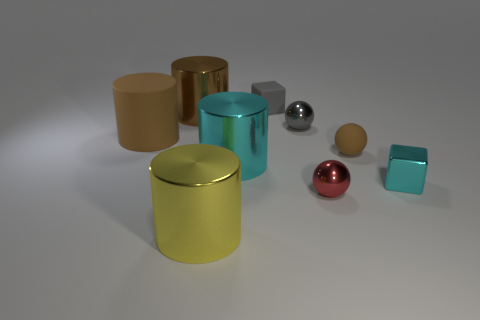Subtract 1 cylinders. How many cylinders are left? 3 Add 1 big cyan rubber spheres. How many objects exist? 10 Subtract all cylinders. How many objects are left? 5 Add 3 tiny red shiny balls. How many tiny red shiny balls are left? 4 Add 3 tiny red spheres. How many tiny red spheres exist? 4 Subtract 0 purple blocks. How many objects are left? 9 Subtract all big cyan rubber cubes. Subtract all rubber balls. How many objects are left? 8 